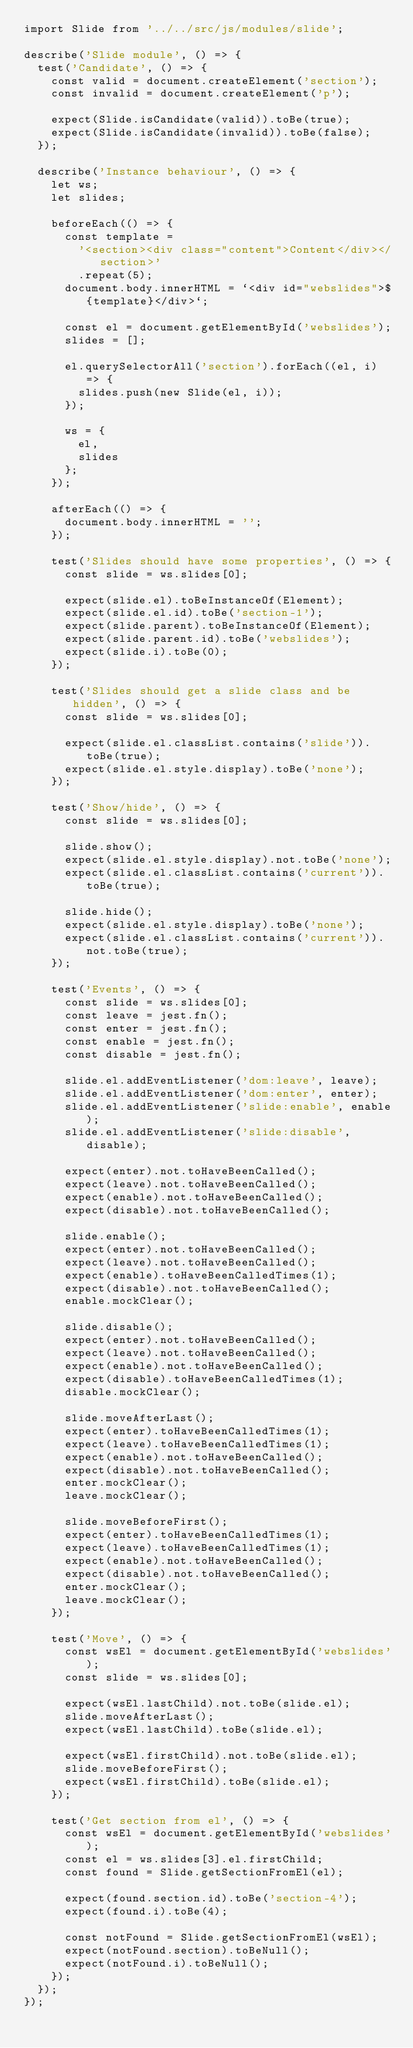Convert code to text. <code><loc_0><loc_0><loc_500><loc_500><_JavaScript_>import Slide from '../../src/js/modules/slide';

describe('Slide module', () => {
  test('Candidate', () => {
    const valid = document.createElement('section');
    const invalid = document.createElement('p');

    expect(Slide.isCandidate(valid)).toBe(true);
    expect(Slide.isCandidate(invalid)).toBe(false);
  });

  describe('Instance behaviour', () => {
    let ws;
    let slides;

    beforeEach(() => {
      const template =
        '<section><div class="content">Content</div></section>'
        .repeat(5);
      document.body.innerHTML = `<div id="webslides">${template}</div>`;

      const el = document.getElementById('webslides');
      slides = [];

      el.querySelectorAll('section').forEach((el, i) => {
        slides.push(new Slide(el, i));
      });

      ws = {
        el,
        slides
      };
    });

    afterEach(() => {
      document.body.innerHTML = '';
    });

    test('Slides should have some properties', () => {
      const slide = ws.slides[0];

      expect(slide.el).toBeInstanceOf(Element);
      expect(slide.el.id).toBe('section-1');
      expect(slide.parent).toBeInstanceOf(Element);
      expect(slide.parent.id).toBe('webslides');
      expect(slide.i).toBe(0);
    });

    test('Slides should get a slide class and be hidden', () => {
      const slide = ws.slides[0];

      expect(slide.el.classList.contains('slide')).toBe(true);
      expect(slide.el.style.display).toBe('none');
    });

    test('Show/hide', () => {
      const slide = ws.slides[0];

      slide.show();
      expect(slide.el.style.display).not.toBe('none');
      expect(slide.el.classList.contains('current')).toBe(true);

      slide.hide();
      expect(slide.el.style.display).toBe('none');
      expect(slide.el.classList.contains('current')).not.toBe(true);
    });

    test('Events', () => {
      const slide = ws.slides[0];
      const leave = jest.fn();
      const enter = jest.fn();
      const enable = jest.fn();
      const disable = jest.fn();

      slide.el.addEventListener('dom:leave', leave);
      slide.el.addEventListener('dom:enter', enter);
      slide.el.addEventListener('slide:enable', enable);
      slide.el.addEventListener('slide:disable', disable);

      expect(enter).not.toHaveBeenCalled();
      expect(leave).not.toHaveBeenCalled();
      expect(enable).not.toHaveBeenCalled();
      expect(disable).not.toHaveBeenCalled();

      slide.enable();
      expect(enter).not.toHaveBeenCalled();
      expect(leave).not.toHaveBeenCalled();
      expect(enable).toHaveBeenCalledTimes(1);
      expect(disable).not.toHaveBeenCalled();
      enable.mockClear();

      slide.disable();
      expect(enter).not.toHaveBeenCalled();
      expect(leave).not.toHaveBeenCalled();
      expect(enable).not.toHaveBeenCalled();
      expect(disable).toHaveBeenCalledTimes(1);
      disable.mockClear();

      slide.moveAfterLast();
      expect(enter).toHaveBeenCalledTimes(1);
      expect(leave).toHaveBeenCalledTimes(1);
      expect(enable).not.toHaveBeenCalled();
      expect(disable).not.toHaveBeenCalled();
      enter.mockClear();
      leave.mockClear();

      slide.moveBeforeFirst();
      expect(enter).toHaveBeenCalledTimes(1);
      expect(leave).toHaveBeenCalledTimes(1);
      expect(enable).not.toHaveBeenCalled();
      expect(disable).not.toHaveBeenCalled();
      enter.mockClear();
      leave.mockClear();
    });

    test('Move', () => {
      const wsEl = document.getElementById('webslides');
      const slide = ws.slides[0];

      expect(wsEl.lastChild).not.toBe(slide.el);
      slide.moveAfterLast();
      expect(wsEl.lastChild).toBe(slide.el);

      expect(wsEl.firstChild).not.toBe(slide.el);
      slide.moveBeforeFirst();
      expect(wsEl.firstChild).toBe(slide.el);
    });

    test('Get section from el', () => {
      const wsEl = document.getElementById('webslides');
      const el = ws.slides[3].el.firstChild;
      const found = Slide.getSectionFromEl(el);

      expect(found.section.id).toBe('section-4');
      expect(found.i).toBe(4);

      const notFound = Slide.getSectionFromEl(wsEl);
      expect(notFound.section).toBeNull();
      expect(notFound.i).toBeNull();
    });
  });
});
</code> 